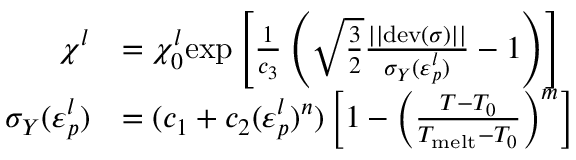<formula> <loc_0><loc_0><loc_500><loc_500>\begin{array} { r l } { \chi ^ { l } } & { = \chi _ { 0 } ^ { l } e x p \left [ \frac { 1 } { c _ { 3 } } \left ( \sqrt { \frac { 3 } { 2 } } \frac { | | d e v ( \boldsymbol \sigma ) | | } { \sigma _ { Y } ( \varepsilon _ { p } ^ { l } ) } - 1 \right ) \right ] } \\ { \sigma _ { Y } ( \varepsilon _ { p } ^ { l } ) } & { = ( c _ { 1 } + c _ { 2 } ( \varepsilon _ { p } ^ { l } ) ^ { n } ) \left [ 1 - \left ( \frac { T - T _ { 0 } } { T _ { m e l t } - T _ { 0 } } \right ) ^ { m } \right ] } \end{array}</formula> 